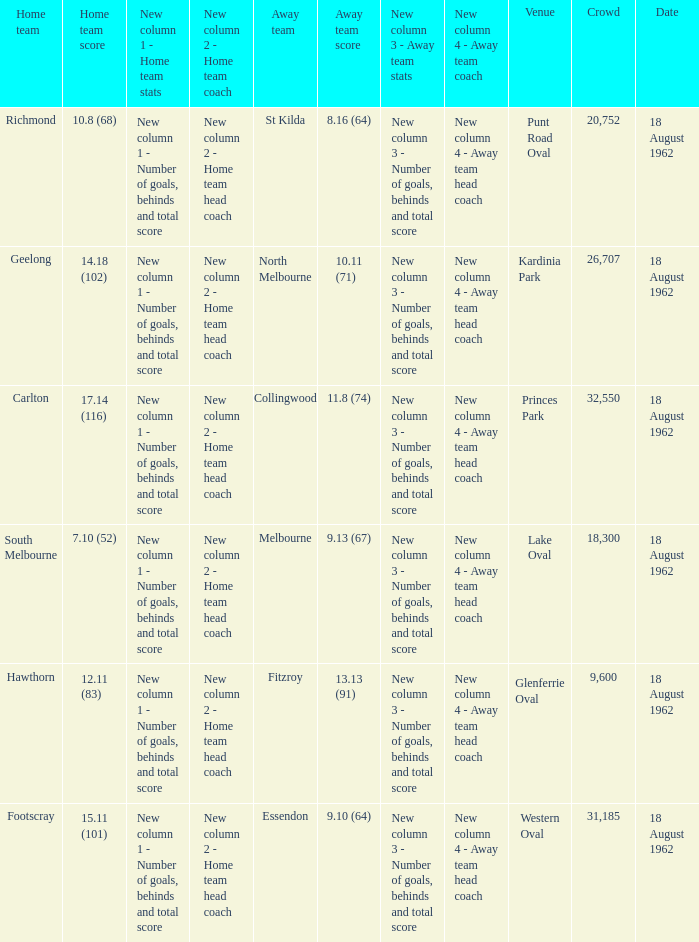At what place where the home team achieved 1 None. 